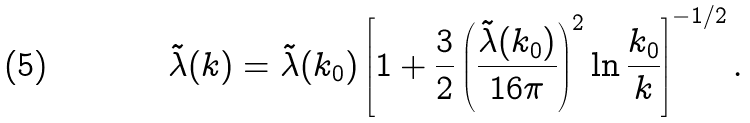<formula> <loc_0><loc_0><loc_500><loc_500>\tilde { \lambda } ( k ) = \tilde { \lambda } ( k _ { 0 } ) \left [ 1 + \frac { 3 } { 2 } \left ( \frac { \tilde { \lambda } ( k _ { 0 } ) } { 1 6 \pi } \right ) ^ { 2 } \ln \frac { k _ { 0 } } { k } \right ] ^ { - 1 / 2 } .</formula> 